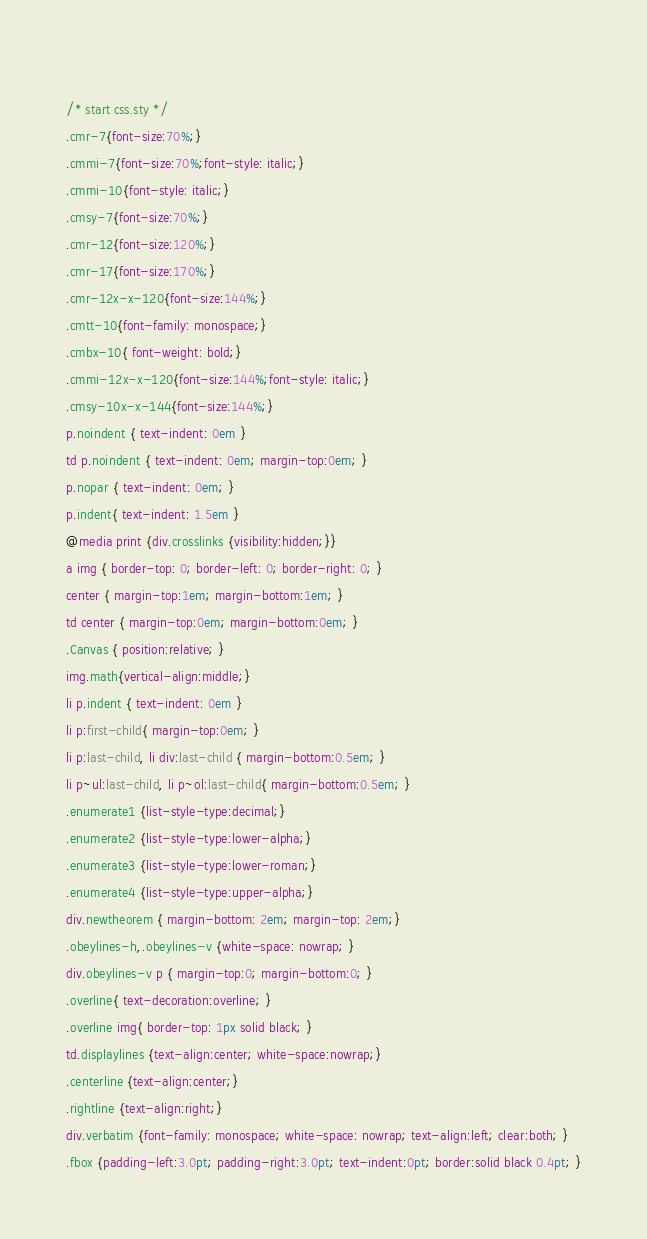<code> <loc_0><loc_0><loc_500><loc_500><_CSS_> 
/* start css.sty */
.cmr-7{font-size:70%;}
.cmmi-7{font-size:70%;font-style: italic;}
.cmmi-10{font-style: italic;}
.cmsy-7{font-size:70%;}
.cmr-12{font-size:120%;}
.cmr-17{font-size:170%;}
.cmr-12x-x-120{font-size:144%;}
.cmtt-10{font-family: monospace;}
.cmbx-10{ font-weight: bold;}
.cmmi-12x-x-120{font-size:144%;font-style: italic;}
.cmsy-10x-x-144{font-size:144%;}
p.noindent { text-indent: 0em }
td p.noindent { text-indent: 0em; margin-top:0em; }
p.nopar { text-indent: 0em; }
p.indent{ text-indent: 1.5em }
@media print {div.crosslinks {visibility:hidden;}}
a img { border-top: 0; border-left: 0; border-right: 0; }
center { margin-top:1em; margin-bottom:1em; }
td center { margin-top:0em; margin-bottom:0em; }
.Canvas { position:relative; }
img.math{vertical-align:middle;}
li p.indent { text-indent: 0em }
li p:first-child{ margin-top:0em; }
li p:last-child, li div:last-child { margin-bottom:0.5em; }
li p~ul:last-child, li p~ol:last-child{ margin-bottom:0.5em; }
.enumerate1 {list-style-type:decimal;}
.enumerate2 {list-style-type:lower-alpha;}
.enumerate3 {list-style-type:lower-roman;}
.enumerate4 {list-style-type:upper-alpha;}
div.newtheorem { margin-bottom: 2em; margin-top: 2em;}
.obeylines-h,.obeylines-v {white-space: nowrap; }
div.obeylines-v p { margin-top:0; margin-bottom:0; }
.overline{ text-decoration:overline; }
.overline img{ border-top: 1px solid black; }
td.displaylines {text-align:center; white-space:nowrap;}
.centerline {text-align:center;}
.rightline {text-align:right;}
div.verbatim {font-family: monospace; white-space: nowrap; text-align:left; clear:both; }
.fbox {padding-left:3.0pt; padding-right:3.0pt; text-indent:0pt; border:solid black 0.4pt; }</code> 